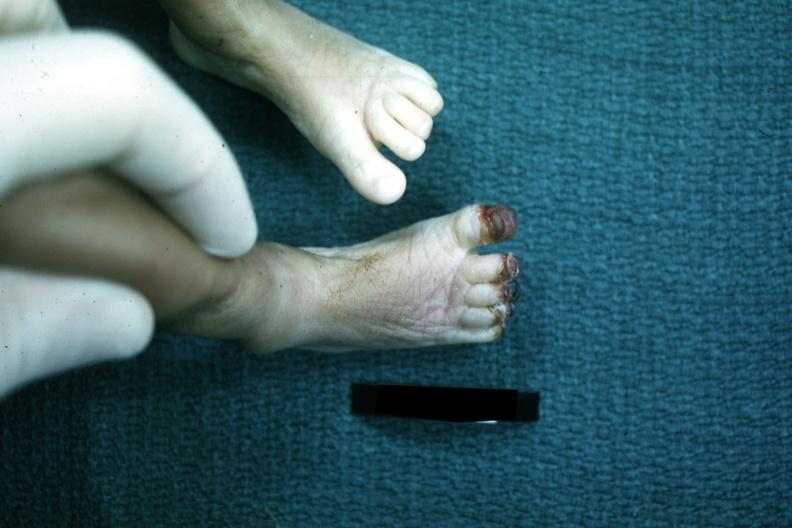does chronic ischemia show foot of infant with gangrenous tips of all toes case of sepsis with dic?
Answer the question using a single word or phrase. No 